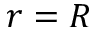<formula> <loc_0><loc_0><loc_500><loc_500>r = R</formula> 